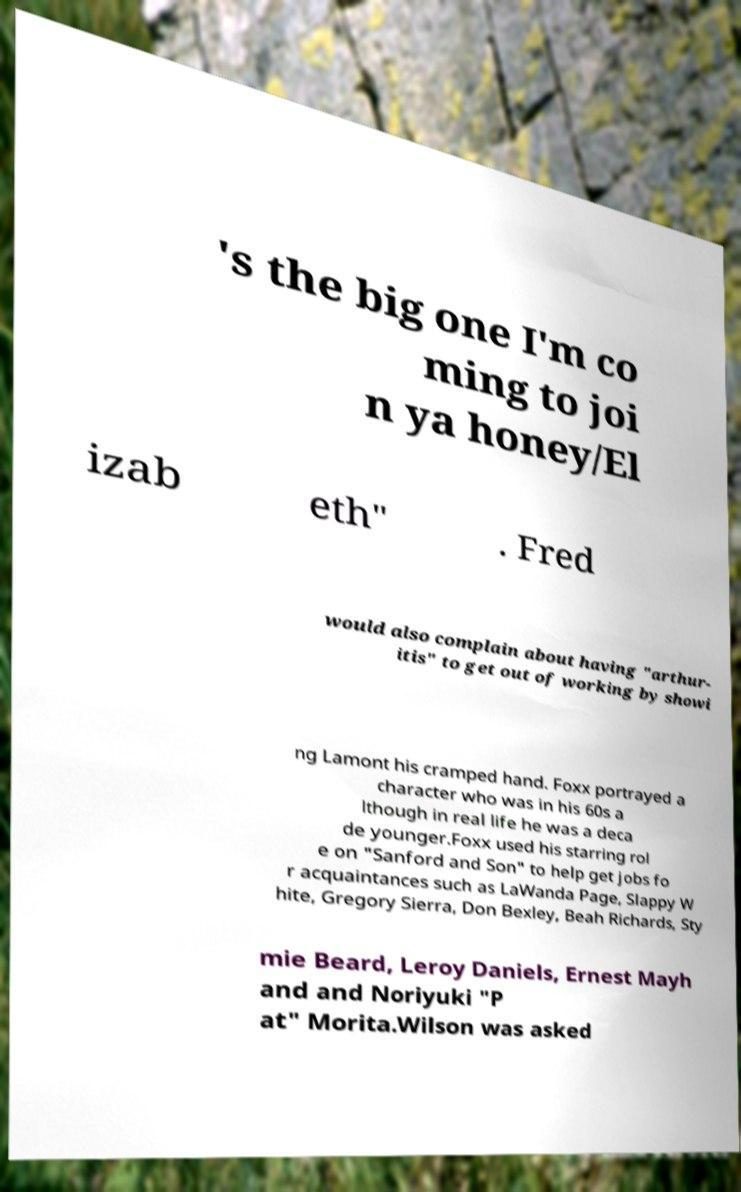There's text embedded in this image that I need extracted. Can you transcribe it verbatim? 's the big one I'm co ming to joi n ya honey/El izab eth" . Fred would also complain about having "arthur- itis" to get out of working by showi ng Lamont his cramped hand. Foxx portrayed a character who was in his 60s a lthough in real life he was a deca de younger.Foxx used his starring rol e on "Sanford and Son" to help get jobs fo r acquaintances such as LaWanda Page, Slappy W hite, Gregory Sierra, Don Bexley, Beah Richards, Sty mie Beard, Leroy Daniels, Ernest Mayh and and Noriyuki "P at" Morita.Wilson was asked 